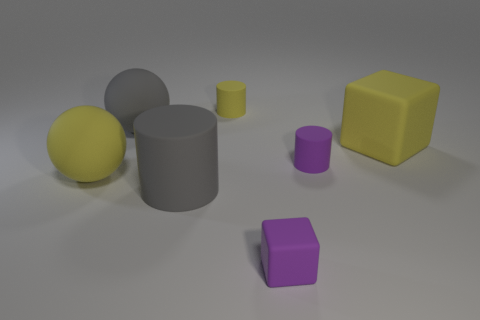Are there any small yellow rubber things in front of the small purple cylinder?
Provide a succinct answer. No. There is a large rubber sphere that is behind the large yellow object left of the tiny yellow matte object; what is its color?
Your response must be concise. Gray. Are there fewer large gray matte cylinders than tiny purple shiny objects?
Make the answer very short. No. What number of gray matte things have the same shape as the small yellow rubber object?
Give a very brief answer. 1. There is another sphere that is the same size as the gray sphere; what color is it?
Your response must be concise. Yellow. Are there an equal number of tiny purple cylinders that are right of the large yellow matte block and large gray cylinders in front of the large gray cylinder?
Provide a succinct answer. Yes. Is there a matte object that has the same size as the gray rubber cylinder?
Your answer should be compact. Yes. What is the size of the purple matte cylinder?
Ensure brevity in your answer.  Small. Is the number of purple cylinders that are left of the yellow cube the same as the number of small red matte cubes?
Ensure brevity in your answer.  No. What number of other things are there of the same color as the big cube?
Provide a short and direct response. 2. 